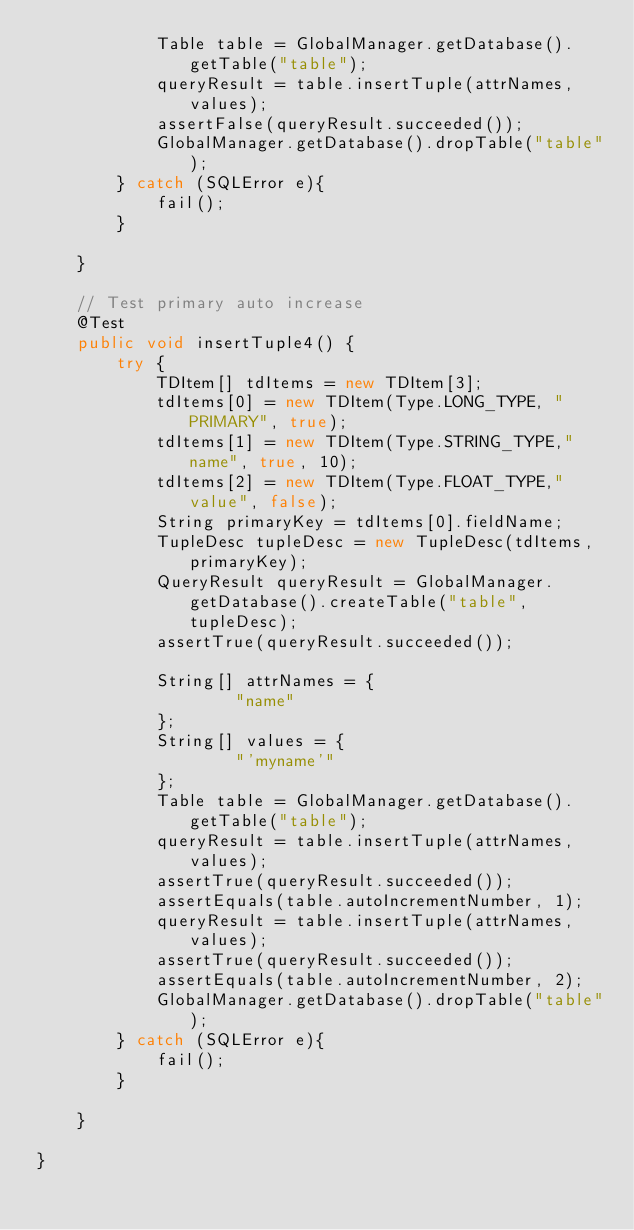<code> <loc_0><loc_0><loc_500><loc_500><_Java_>            Table table = GlobalManager.getDatabase().getTable("table");
            queryResult = table.insertTuple(attrNames, values);
            assertFalse(queryResult.succeeded());
            GlobalManager.getDatabase().dropTable("table");
        } catch (SQLError e){
            fail();
        }

    }

    // Test primary auto increase
    @Test
    public void insertTuple4() {
        try {
            TDItem[] tdItems = new TDItem[3];
            tdItems[0] = new TDItem(Type.LONG_TYPE, "PRIMARY", true);
            tdItems[1] = new TDItem(Type.STRING_TYPE,"name", true, 10);
            tdItems[2] = new TDItem(Type.FLOAT_TYPE,"value", false);
            String primaryKey = tdItems[0].fieldName;
            TupleDesc tupleDesc = new TupleDesc(tdItems, primaryKey);
            QueryResult queryResult = GlobalManager.getDatabase().createTable("table", tupleDesc);
            assertTrue(queryResult.succeeded());

            String[] attrNames = {
                    "name"
            };
            String[] values = {
                    "'myname'"
            };
            Table table = GlobalManager.getDatabase().getTable("table");
            queryResult = table.insertTuple(attrNames, values);
            assertTrue(queryResult.succeeded());
            assertEquals(table.autoIncrementNumber, 1);
            queryResult = table.insertTuple(attrNames, values);
            assertTrue(queryResult.succeeded());
            assertEquals(table.autoIncrementNumber, 2);
            GlobalManager.getDatabase().dropTable("table");
        } catch (SQLError e){
            fail();
        }

    }

}</code> 